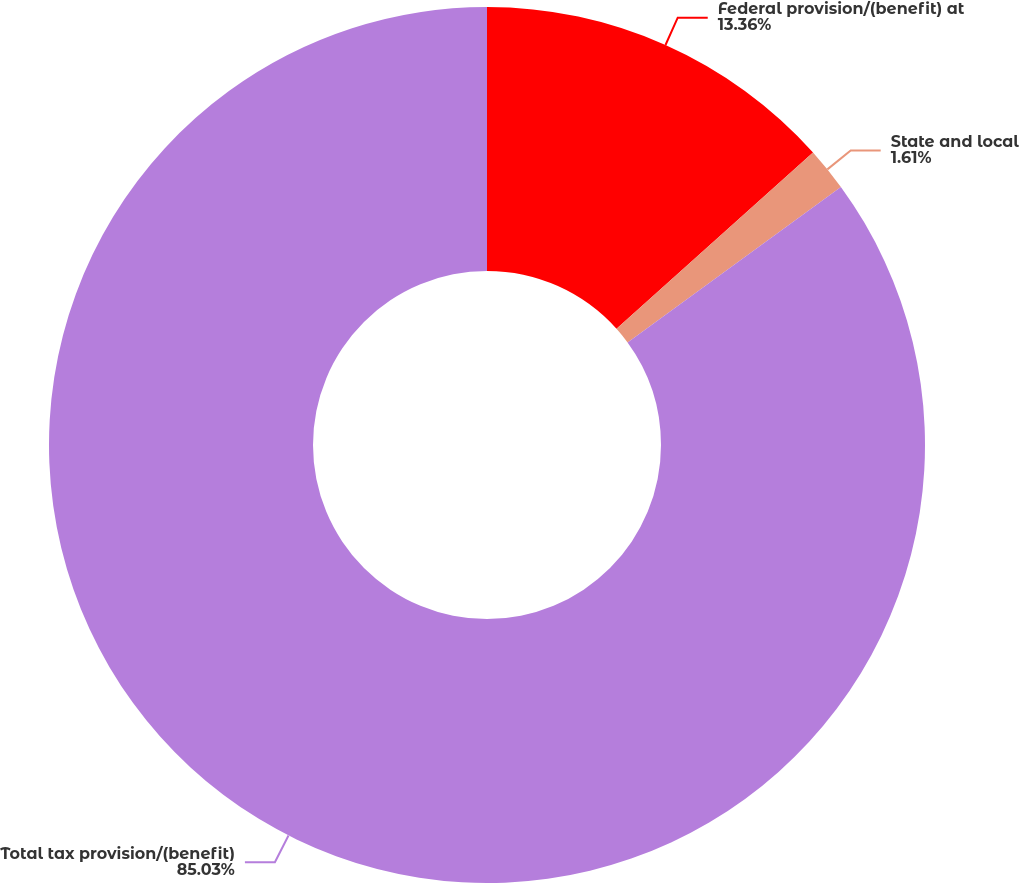Convert chart. <chart><loc_0><loc_0><loc_500><loc_500><pie_chart><fcel>Federal provision/(benefit) at<fcel>State and local<fcel>Total tax provision/(benefit)<nl><fcel>13.36%<fcel>1.61%<fcel>85.02%<nl></chart> 